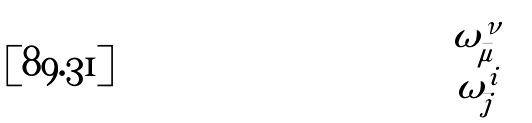Convert formula to latex. <formula><loc_0><loc_0><loc_500><loc_500>\begin{pmatrix} \omega ^ { \nu } _ { \bar { \mu } } \\ \omega ^ { i } _ { \bar { j } } \end{pmatrix}</formula> 